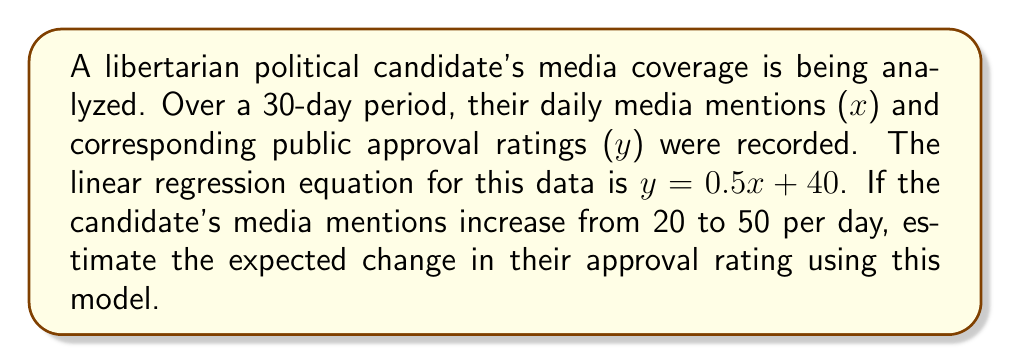Solve this math problem. Let's approach this step-by-step:

1) We have a linear regression equation: $y = 0.5x + 40$
   Where $x$ is the number of daily media mentions and $y$ is the approval rating.

2) We need to calculate the change in $y$ when $x$ changes from 20 to 50.

3) Let's calculate $y$ for $x = 20$:
   $y_1 = 0.5(20) + 40 = 10 + 40 = 50$

4) Now, let's calculate $y$ for $x = 50$:
   $y_2 = 0.5(50) + 40 = 25 + 40 = 65$

5) The change in approval rating is the difference between these two values:
   $\Delta y = y_2 - y_1 = 65 - 50 = 15$

Therefore, the model estimates that increasing daily media mentions from 20 to 50 would result in a 15-point increase in the approval rating.
Answer: 15 points 